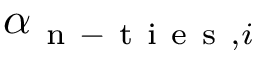<formula> <loc_0><loc_0><loc_500><loc_500>\alpha _ { n - t i e s , i }</formula> 